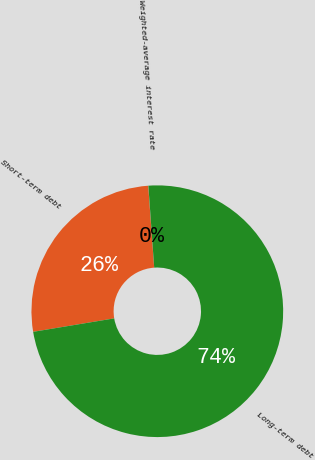Convert chart to OTSL. <chart><loc_0><loc_0><loc_500><loc_500><pie_chart><fcel>Short-term debt<fcel>Long-term debt<fcel>Weighted-average interest rate<nl><fcel>26.47%<fcel>73.52%<fcel>0.01%<nl></chart> 